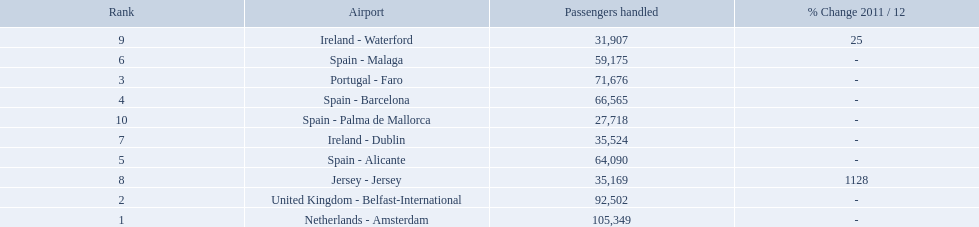What are the numbers of passengers handled along the different routes in the airport? 105,349, 92,502, 71,676, 66,565, 64,090, 59,175, 35,524, 35,169, 31,907, 27,718. Of these routes, which handles less than 30,000 passengers? Spain - Palma de Mallorca. 